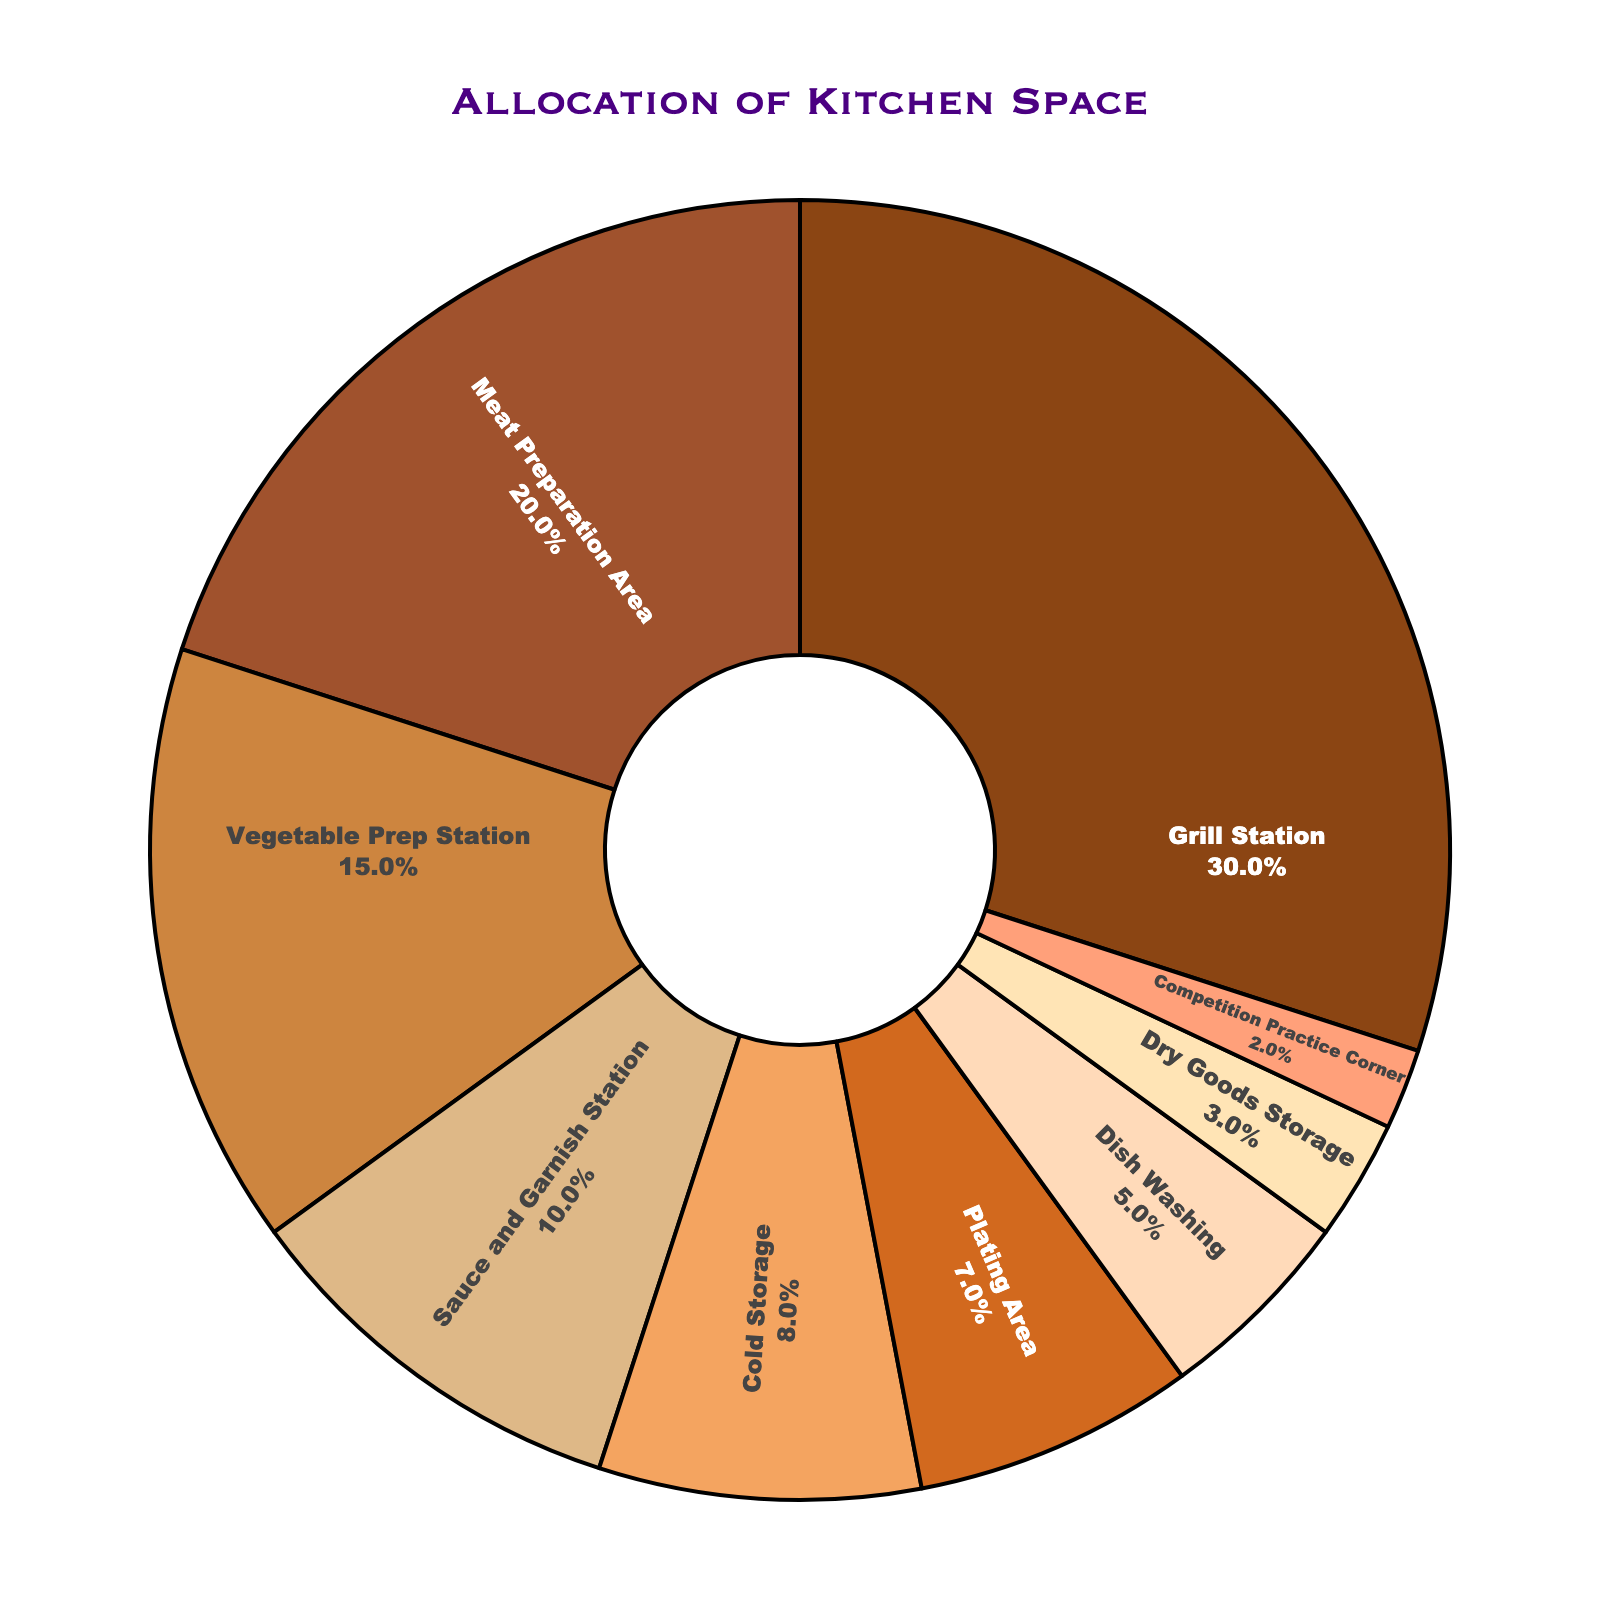What's the percentage allocation for the Grill Station? The Grill Station's slice of the pie chart is labeled as 30%.
Answer: 30% How much space is allocated to both the Meat Preparation Area and the Vegetable Prep Station combined? The Meat Preparation Area is at 20% and the Vegetable Prep Station is at 15%. Adding them together, 20% + 15% = 35%.
Answer: 35% Which station has the smallest allocation of kitchen space? The pie chart shows that the Competition Practice Corner takes up 2%, which is the smallest allocation.
Answer: Competition Practice Corner Is the space allocated for Cold Storage greater than that for Plating Area? Cold Storage is allocated 8%, while Plating Area is given 7%. Since 8% is greater than 7%, Cold Storage has more space.
Answer: Yes How much more space does the Grill Station have compared to the Dish Washing area? The Grill Station is allocated 30%, and the Dish Washing is allotted 5%. The difference is 30% - 5% = 25%.
Answer: 25% Combine the space allocated for Sauce and Garnish Station, Cold Storage, and Dry Goods Storage. What is the total percentage? The Sauce and Garnish Station is at 10%, Cold Storage is at 8%, and Dry Goods Storage is at 3%. Adding them together, 10% + 8% + 3% = 21%.
Answer: 21% Which station has a higher allocation: Meat Preparation Area or Vegetable Prep Station? The Meat Preparation Area is shown at 20%, while the Vegetable Prep Station is at 15%. Since 20% > 15%, the Meat Preparation Area has a higher allocation.
Answer: Meat Preparation Area What's the combined space allocation for non-preparation areas (excluding Grill Station, Meat Preparation Area, and Vegetable Prep Station)? Adding the percentages for non-preparation areas: Sauce and Garnish Station (10%) + Cold Storage (8%) + Plating Area (7%) + Dish Washing (5%) + Dry Goods Storage (3%) + Competition Practice Corner (2%) = 35%.
Answer: 35% Is the Meat Preparation Area's allocation closer to that of the Grill Station or the Vegetable Prep Station? The Meat Preparation Area is at 20%. The difference with the Grill Station (30%) is 10% (30% - 20%), and with the Vegetable Prep Station (15%) is 5% (20% - 15%). Since 5% is less than 10%, it is closer to the Vegetable Prep Station.
Answer: Vegetable Prep Station Which station has a higher allocation, Plating Area or Dry Goods Storage? The pie chart shows the Plating Area at 7% and Dry Goods Storage at 3%. Since 7% > 3%, Plating Area has a higher space allocation.
Answer: Plating Area 